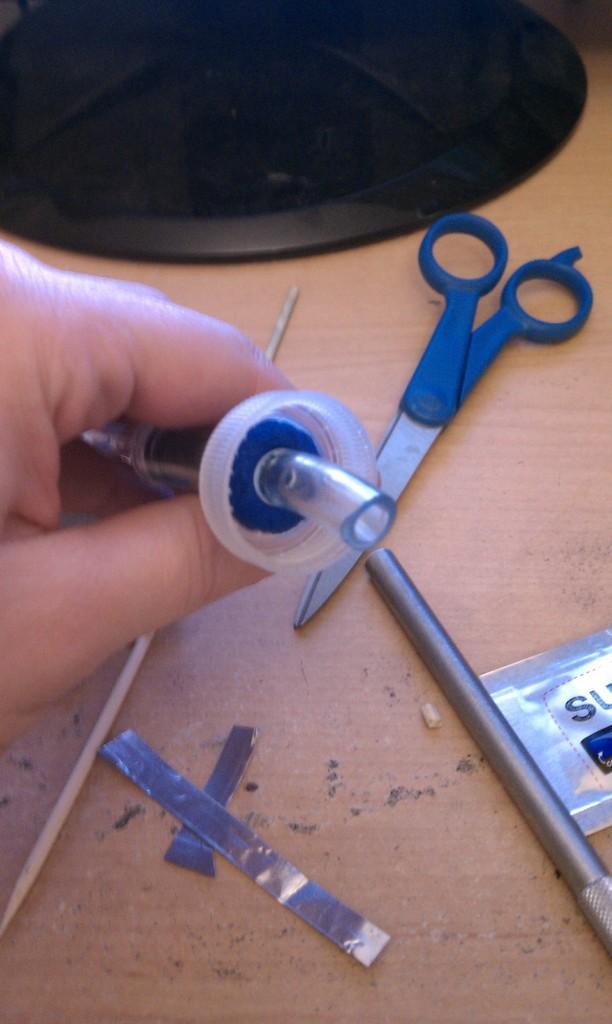Can you describe this image briefly? In this image we can see hand of a person. On that we can see an object in the hand. And we can see a wooden surface. On that there is scissors, stick, tape and some other items. 